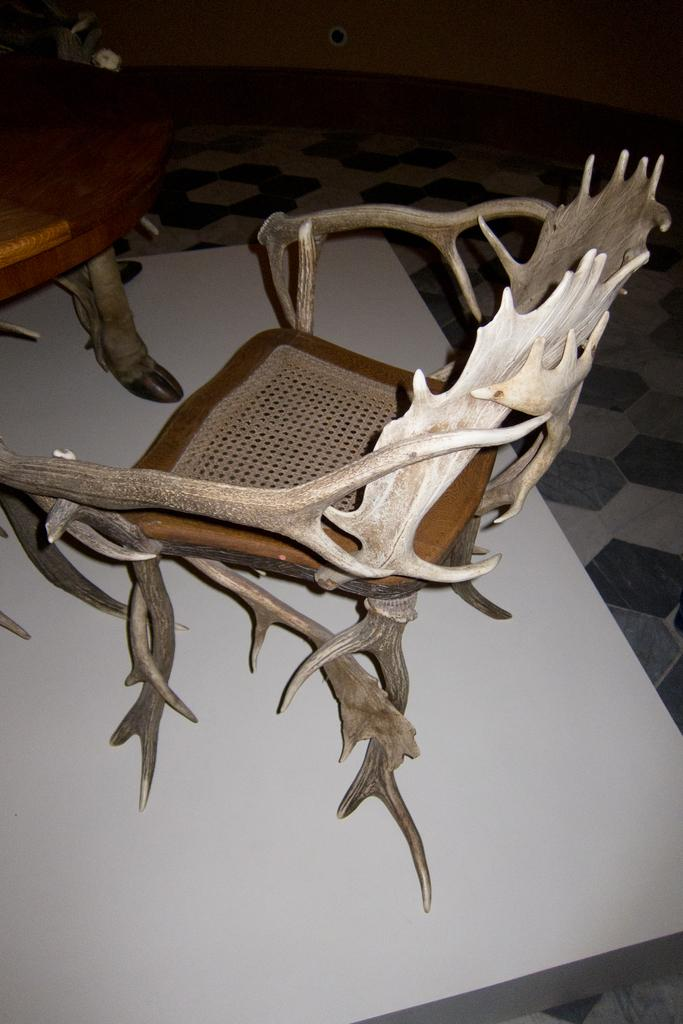How many chairs are in the image? There are two chairs in the image. Where are the chairs located? The chairs are on a surface. What can be seen in the background of the image? There is a floor and a wall visible in the background of the image. What type of cloth is draped over the chairs in the image? There is no cloth draped over the chairs in the image. How many nails can be seen holding the chairs to the surface in the image? There is no mention of nails or any fastening method in the image; the chairs are simply on a surface. 